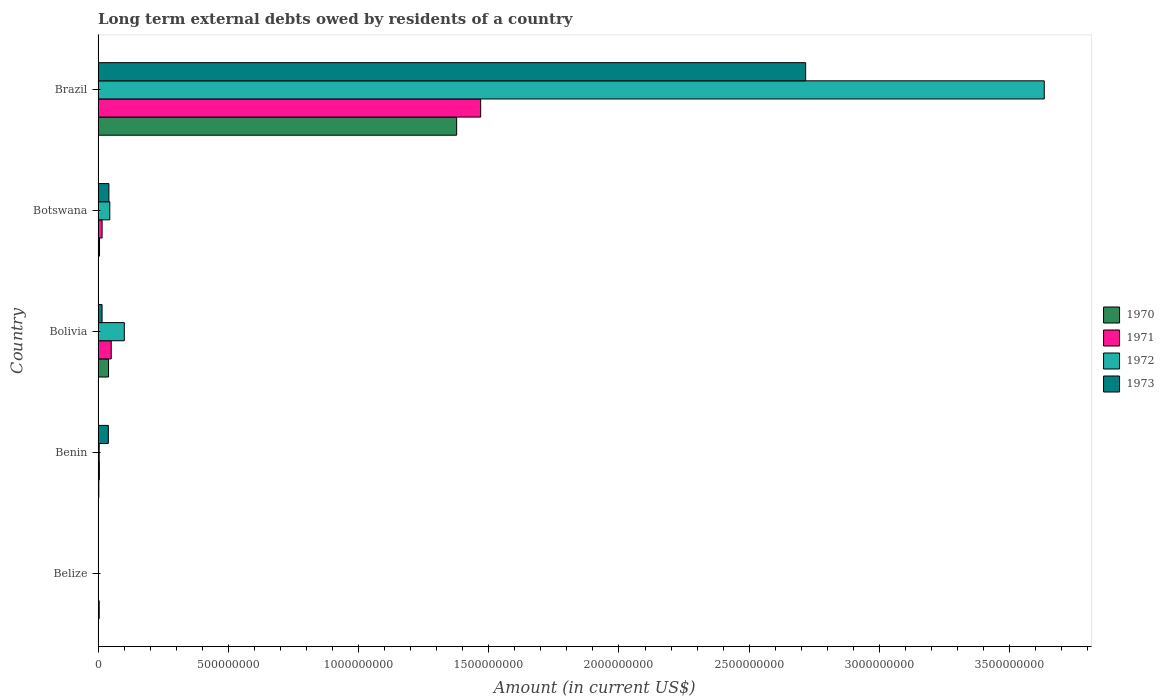How many different coloured bars are there?
Make the answer very short. 4. Are the number of bars on each tick of the Y-axis equal?
Provide a succinct answer. No. In how many cases, is the number of bars for a given country not equal to the number of legend labels?
Keep it short and to the point. 1. What is the amount of long-term external debts owed by residents in 1973 in Bolivia?
Your answer should be compact. 1.53e+07. Across all countries, what is the maximum amount of long-term external debts owed by residents in 1973?
Give a very brief answer. 2.72e+09. Across all countries, what is the minimum amount of long-term external debts owed by residents in 1970?
Provide a short and direct response. 2.87e+06. In which country was the amount of long-term external debts owed by residents in 1971 maximum?
Keep it short and to the point. Brazil. What is the total amount of long-term external debts owed by residents in 1970 in the graph?
Make the answer very short. 1.43e+09. What is the difference between the amount of long-term external debts owed by residents in 1970 in Belize and that in Brazil?
Give a very brief answer. -1.37e+09. What is the difference between the amount of long-term external debts owed by residents in 1970 in Belize and the amount of long-term external debts owed by residents in 1972 in Benin?
Give a very brief answer. 2.40e+04. What is the average amount of long-term external debts owed by residents in 1971 per country?
Your answer should be very brief. 3.08e+08. What is the difference between the amount of long-term external debts owed by residents in 1971 and amount of long-term external debts owed by residents in 1970 in Bolivia?
Keep it short and to the point. 1.03e+07. In how many countries, is the amount of long-term external debts owed by residents in 1973 greater than 2400000000 US$?
Offer a terse response. 1. What is the ratio of the amount of long-term external debts owed by residents in 1972 in Benin to that in Bolivia?
Your answer should be compact. 0.04. Is the amount of long-term external debts owed by residents in 1973 in Bolivia less than that in Brazil?
Provide a short and direct response. Yes. What is the difference between the highest and the second highest amount of long-term external debts owed by residents in 1970?
Your answer should be compact. 1.34e+09. What is the difference between the highest and the lowest amount of long-term external debts owed by residents in 1971?
Provide a short and direct response. 1.47e+09. Is it the case that in every country, the sum of the amount of long-term external debts owed by residents in 1971 and amount of long-term external debts owed by residents in 1972 is greater than the sum of amount of long-term external debts owed by residents in 1973 and amount of long-term external debts owed by residents in 1970?
Your response must be concise. No. Is it the case that in every country, the sum of the amount of long-term external debts owed by residents in 1973 and amount of long-term external debts owed by residents in 1972 is greater than the amount of long-term external debts owed by residents in 1971?
Your response must be concise. No. What is the difference between two consecutive major ticks on the X-axis?
Your response must be concise. 5.00e+08. Does the graph contain any zero values?
Offer a terse response. Yes. Does the graph contain grids?
Provide a succinct answer. No. Where does the legend appear in the graph?
Provide a short and direct response. Center right. How are the legend labels stacked?
Your answer should be compact. Vertical. What is the title of the graph?
Make the answer very short. Long term external debts owed by residents of a country. What is the label or title of the Y-axis?
Your answer should be very brief. Country. What is the Amount (in current US$) of 1970 in Belize?
Keep it short and to the point. 4.30e+06. What is the Amount (in current US$) in 1971 in Belize?
Offer a terse response. 0. What is the Amount (in current US$) in 1973 in Belize?
Keep it short and to the point. 0. What is the Amount (in current US$) of 1970 in Benin?
Your response must be concise. 2.87e+06. What is the Amount (in current US$) of 1971 in Benin?
Your response must be concise. 4.99e+06. What is the Amount (in current US$) in 1972 in Benin?
Ensure brevity in your answer.  4.28e+06. What is the Amount (in current US$) in 1973 in Benin?
Make the answer very short. 3.93e+07. What is the Amount (in current US$) in 1970 in Bolivia?
Make the answer very short. 4.01e+07. What is the Amount (in current US$) in 1971 in Bolivia?
Keep it short and to the point. 5.04e+07. What is the Amount (in current US$) in 1972 in Bolivia?
Provide a succinct answer. 1.01e+08. What is the Amount (in current US$) of 1973 in Bolivia?
Your answer should be very brief. 1.53e+07. What is the Amount (in current US$) of 1970 in Botswana?
Offer a very short reply. 5.57e+06. What is the Amount (in current US$) of 1971 in Botswana?
Provide a short and direct response. 1.54e+07. What is the Amount (in current US$) in 1972 in Botswana?
Make the answer very short. 4.50e+07. What is the Amount (in current US$) of 1973 in Botswana?
Provide a succinct answer. 4.15e+07. What is the Amount (in current US$) in 1970 in Brazil?
Offer a terse response. 1.38e+09. What is the Amount (in current US$) in 1971 in Brazil?
Your response must be concise. 1.47e+09. What is the Amount (in current US$) of 1972 in Brazil?
Give a very brief answer. 3.63e+09. What is the Amount (in current US$) of 1973 in Brazil?
Make the answer very short. 2.72e+09. Across all countries, what is the maximum Amount (in current US$) in 1970?
Make the answer very short. 1.38e+09. Across all countries, what is the maximum Amount (in current US$) in 1971?
Offer a terse response. 1.47e+09. Across all countries, what is the maximum Amount (in current US$) of 1972?
Provide a succinct answer. 3.63e+09. Across all countries, what is the maximum Amount (in current US$) of 1973?
Offer a terse response. 2.72e+09. Across all countries, what is the minimum Amount (in current US$) in 1970?
Your answer should be very brief. 2.87e+06. Across all countries, what is the minimum Amount (in current US$) in 1972?
Your answer should be compact. 0. Across all countries, what is the minimum Amount (in current US$) of 1973?
Provide a succinct answer. 0. What is the total Amount (in current US$) in 1970 in the graph?
Offer a very short reply. 1.43e+09. What is the total Amount (in current US$) in 1971 in the graph?
Your answer should be very brief. 1.54e+09. What is the total Amount (in current US$) in 1972 in the graph?
Provide a succinct answer. 3.78e+09. What is the total Amount (in current US$) in 1973 in the graph?
Give a very brief answer. 2.81e+09. What is the difference between the Amount (in current US$) of 1970 in Belize and that in Benin?
Your answer should be compact. 1.43e+06. What is the difference between the Amount (in current US$) in 1970 in Belize and that in Bolivia?
Provide a succinct answer. -3.58e+07. What is the difference between the Amount (in current US$) of 1970 in Belize and that in Botswana?
Offer a very short reply. -1.27e+06. What is the difference between the Amount (in current US$) in 1970 in Belize and that in Brazil?
Offer a terse response. -1.37e+09. What is the difference between the Amount (in current US$) in 1970 in Benin and that in Bolivia?
Provide a succinct answer. -3.72e+07. What is the difference between the Amount (in current US$) in 1971 in Benin and that in Bolivia?
Provide a short and direct response. -4.54e+07. What is the difference between the Amount (in current US$) of 1972 in Benin and that in Bolivia?
Ensure brevity in your answer.  -9.64e+07. What is the difference between the Amount (in current US$) in 1973 in Benin and that in Bolivia?
Your answer should be very brief. 2.40e+07. What is the difference between the Amount (in current US$) in 1970 in Benin and that in Botswana?
Offer a very short reply. -2.70e+06. What is the difference between the Amount (in current US$) in 1971 in Benin and that in Botswana?
Offer a very short reply. -1.04e+07. What is the difference between the Amount (in current US$) in 1972 in Benin and that in Botswana?
Provide a succinct answer. -4.07e+07. What is the difference between the Amount (in current US$) of 1973 in Benin and that in Botswana?
Provide a short and direct response. -2.15e+06. What is the difference between the Amount (in current US$) of 1970 in Benin and that in Brazil?
Give a very brief answer. -1.37e+09. What is the difference between the Amount (in current US$) of 1971 in Benin and that in Brazil?
Your response must be concise. -1.46e+09. What is the difference between the Amount (in current US$) of 1972 in Benin and that in Brazil?
Give a very brief answer. -3.63e+09. What is the difference between the Amount (in current US$) in 1973 in Benin and that in Brazil?
Provide a short and direct response. -2.68e+09. What is the difference between the Amount (in current US$) in 1970 in Bolivia and that in Botswana?
Ensure brevity in your answer.  3.45e+07. What is the difference between the Amount (in current US$) in 1971 in Bolivia and that in Botswana?
Ensure brevity in your answer.  3.50e+07. What is the difference between the Amount (in current US$) in 1972 in Bolivia and that in Botswana?
Your answer should be compact. 5.57e+07. What is the difference between the Amount (in current US$) in 1973 in Bolivia and that in Botswana?
Provide a succinct answer. -2.62e+07. What is the difference between the Amount (in current US$) in 1970 in Bolivia and that in Brazil?
Keep it short and to the point. -1.34e+09. What is the difference between the Amount (in current US$) in 1971 in Bolivia and that in Brazil?
Make the answer very short. -1.42e+09. What is the difference between the Amount (in current US$) in 1972 in Bolivia and that in Brazil?
Your response must be concise. -3.53e+09. What is the difference between the Amount (in current US$) of 1973 in Bolivia and that in Brazil?
Make the answer very short. -2.70e+09. What is the difference between the Amount (in current US$) of 1970 in Botswana and that in Brazil?
Give a very brief answer. -1.37e+09. What is the difference between the Amount (in current US$) in 1971 in Botswana and that in Brazil?
Ensure brevity in your answer.  -1.45e+09. What is the difference between the Amount (in current US$) of 1972 in Botswana and that in Brazil?
Make the answer very short. -3.59e+09. What is the difference between the Amount (in current US$) in 1973 in Botswana and that in Brazil?
Offer a very short reply. -2.68e+09. What is the difference between the Amount (in current US$) of 1970 in Belize and the Amount (in current US$) of 1971 in Benin?
Provide a succinct answer. -6.88e+05. What is the difference between the Amount (in current US$) in 1970 in Belize and the Amount (in current US$) in 1972 in Benin?
Provide a short and direct response. 2.40e+04. What is the difference between the Amount (in current US$) of 1970 in Belize and the Amount (in current US$) of 1973 in Benin?
Keep it short and to the point. -3.50e+07. What is the difference between the Amount (in current US$) in 1970 in Belize and the Amount (in current US$) in 1971 in Bolivia?
Make the answer very short. -4.61e+07. What is the difference between the Amount (in current US$) of 1970 in Belize and the Amount (in current US$) of 1972 in Bolivia?
Provide a succinct answer. -9.63e+07. What is the difference between the Amount (in current US$) in 1970 in Belize and the Amount (in current US$) in 1973 in Bolivia?
Offer a terse response. -1.10e+07. What is the difference between the Amount (in current US$) of 1970 in Belize and the Amount (in current US$) of 1971 in Botswana?
Make the answer very short. -1.11e+07. What is the difference between the Amount (in current US$) in 1970 in Belize and the Amount (in current US$) in 1972 in Botswana?
Provide a succinct answer. -4.07e+07. What is the difference between the Amount (in current US$) of 1970 in Belize and the Amount (in current US$) of 1973 in Botswana?
Provide a short and direct response. -3.72e+07. What is the difference between the Amount (in current US$) in 1970 in Belize and the Amount (in current US$) in 1971 in Brazil?
Provide a short and direct response. -1.46e+09. What is the difference between the Amount (in current US$) of 1970 in Belize and the Amount (in current US$) of 1972 in Brazil?
Ensure brevity in your answer.  -3.63e+09. What is the difference between the Amount (in current US$) of 1970 in Belize and the Amount (in current US$) of 1973 in Brazil?
Make the answer very short. -2.71e+09. What is the difference between the Amount (in current US$) in 1970 in Benin and the Amount (in current US$) in 1971 in Bolivia?
Your response must be concise. -4.75e+07. What is the difference between the Amount (in current US$) of 1970 in Benin and the Amount (in current US$) of 1972 in Bolivia?
Ensure brevity in your answer.  -9.78e+07. What is the difference between the Amount (in current US$) in 1970 in Benin and the Amount (in current US$) in 1973 in Bolivia?
Make the answer very short. -1.24e+07. What is the difference between the Amount (in current US$) in 1971 in Benin and the Amount (in current US$) in 1972 in Bolivia?
Keep it short and to the point. -9.57e+07. What is the difference between the Amount (in current US$) in 1971 in Benin and the Amount (in current US$) in 1973 in Bolivia?
Ensure brevity in your answer.  -1.03e+07. What is the difference between the Amount (in current US$) of 1972 in Benin and the Amount (in current US$) of 1973 in Bolivia?
Make the answer very short. -1.10e+07. What is the difference between the Amount (in current US$) of 1970 in Benin and the Amount (in current US$) of 1971 in Botswana?
Offer a very short reply. -1.25e+07. What is the difference between the Amount (in current US$) in 1970 in Benin and the Amount (in current US$) in 1972 in Botswana?
Provide a short and direct response. -4.21e+07. What is the difference between the Amount (in current US$) of 1970 in Benin and the Amount (in current US$) of 1973 in Botswana?
Your answer should be very brief. -3.86e+07. What is the difference between the Amount (in current US$) of 1971 in Benin and the Amount (in current US$) of 1972 in Botswana?
Your response must be concise. -4.00e+07. What is the difference between the Amount (in current US$) in 1971 in Benin and the Amount (in current US$) in 1973 in Botswana?
Your answer should be very brief. -3.65e+07. What is the difference between the Amount (in current US$) in 1972 in Benin and the Amount (in current US$) in 1973 in Botswana?
Make the answer very short. -3.72e+07. What is the difference between the Amount (in current US$) of 1970 in Benin and the Amount (in current US$) of 1971 in Brazil?
Make the answer very short. -1.47e+09. What is the difference between the Amount (in current US$) in 1970 in Benin and the Amount (in current US$) in 1972 in Brazil?
Ensure brevity in your answer.  -3.63e+09. What is the difference between the Amount (in current US$) of 1970 in Benin and the Amount (in current US$) of 1973 in Brazil?
Give a very brief answer. -2.71e+09. What is the difference between the Amount (in current US$) of 1971 in Benin and the Amount (in current US$) of 1972 in Brazil?
Provide a succinct answer. -3.63e+09. What is the difference between the Amount (in current US$) in 1971 in Benin and the Amount (in current US$) in 1973 in Brazil?
Ensure brevity in your answer.  -2.71e+09. What is the difference between the Amount (in current US$) of 1972 in Benin and the Amount (in current US$) of 1973 in Brazil?
Offer a very short reply. -2.71e+09. What is the difference between the Amount (in current US$) of 1970 in Bolivia and the Amount (in current US$) of 1971 in Botswana?
Provide a succinct answer. 2.47e+07. What is the difference between the Amount (in current US$) in 1970 in Bolivia and the Amount (in current US$) in 1972 in Botswana?
Ensure brevity in your answer.  -4.88e+06. What is the difference between the Amount (in current US$) of 1970 in Bolivia and the Amount (in current US$) of 1973 in Botswana?
Offer a terse response. -1.40e+06. What is the difference between the Amount (in current US$) in 1971 in Bolivia and the Amount (in current US$) in 1972 in Botswana?
Your response must be concise. 5.46e+06. What is the difference between the Amount (in current US$) in 1971 in Bolivia and the Amount (in current US$) in 1973 in Botswana?
Your answer should be very brief. 8.94e+06. What is the difference between the Amount (in current US$) in 1972 in Bolivia and the Amount (in current US$) in 1973 in Botswana?
Your answer should be very brief. 5.92e+07. What is the difference between the Amount (in current US$) of 1970 in Bolivia and the Amount (in current US$) of 1971 in Brazil?
Make the answer very short. -1.43e+09. What is the difference between the Amount (in current US$) of 1970 in Bolivia and the Amount (in current US$) of 1972 in Brazil?
Make the answer very short. -3.59e+09. What is the difference between the Amount (in current US$) of 1970 in Bolivia and the Amount (in current US$) of 1973 in Brazil?
Give a very brief answer. -2.68e+09. What is the difference between the Amount (in current US$) of 1971 in Bolivia and the Amount (in current US$) of 1972 in Brazil?
Provide a succinct answer. -3.58e+09. What is the difference between the Amount (in current US$) in 1971 in Bolivia and the Amount (in current US$) in 1973 in Brazil?
Your answer should be very brief. -2.67e+09. What is the difference between the Amount (in current US$) in 1972 in Bolivia and the Amount (in current US$) in 1973 in Brazil?
Ensure brevity in your answer.  -2.62e+09. What is the difference between the Amount (in current US$) in 1970 in Botswana and the Amount (in current US$) in 1971 in Brazil?
Ensure brevity in your answer.  -1.46e+09. What is the difference between the Amount (in current US$) of 1970 in Botswana and the Amount (in current US$) of 1972 in Brazil?
Provide a succinct answer. -3.63e+09. What is the difference between the Amount (in current US$) in 1970 in Botswana and the Amount (in current US$) in 1973 in Brazil?
Your answer should be very brief. -2.71e+09. What is the difference between the Amount (in current US$) in 1971 in Botswana and the Amount (in current US$) in 1972 in Brazil?
Offer a terse response. -3.62e+09. What is the difference between the Amount (in current US$) in 1971 in Botswana and the Amount (in current US$) in 1973 in Brazil?
Your answer should be compact. -2.70e+09. What is the difference between the Amount (in current US$) of 1972 in Botswana and the Amount (in current US$) of 1973 in Brazil?
Your response must be concise. -2.67e+09. What is the average Amount (in current US$) in 1970 per country?
Provide a succinct answer. 2.86e+08. What is the average Amount (in current US$) of 1971 per country?
Your answer should be very brief. 3.08e+08. What is the average Amount (in current US$) in 1972 per country?
Keep it short and to the point. 7.57e+08. What is the average Amount (in current US$) of 1973 per country?
Your answer should be compact. 5.63e+08. What is the difference between the Amount (in current US$) of 1970 and Amount (in current US$) of 1971 in Benin?
Provide a succinct answer. -2.12e+06. What is the difference between the Amount (in current US$) in 1970 and Amount (in current US$) in 1972 in Benin?
Ensure brevity in your answer.  -1.41e+06. What is the difference between the Amount (in current US$) in 1970 and Amount (in current US$) in 1973 in Benin?
Give a very brief answer. -3.65e+07. What is the difference between the Amount (in current US$) of 1971 and Amount (in current US$) of 1972 in Benin?
Make the answer very short. 7.12e+05. What is the difference between the Amount (in current US$) of 1971 and Amount (in current US$) of 1973 in Benin?
Your answer should be very brief. -3.43e+07. What is the difference between the Amount (in current US$) in 1972 and Amount (in current US$) in 1973 in Benin?
Provide a short and direct response. -3.51e+07. What is the difference between the Amount (in current US$) in 1970 and Amount (in current US$) in 1971 in Bolivia?
Your response must be concise. -1.03e+07. What is the difference between the Amount (in current US$) in 1970 and Amount (in current US$) in 1972 in Bolivia?
Offer a very short reply. -6.06e+07. What is the difference between the Amount (in current US$) of 1970 and Amount (in current US$) of 1973 in Bolivia?
Offer a terse response. 2.48e+07. What is the difference between the Amount (in current US$) in 1971 and Amount (in current US$) in 1972 in Bolivia?
Offer a very short reply. -5.02e+07. What is the difference between the Amount (in current US$) of 1971 and Amount (in current US$) of 1973 in Bolivia?
Provide a short and direct response. 3.51e+07. What is the difference between the Amount (in current US$) of 1972 and Amount (in current US$) of 1973 in Bolivia?
Your response must be concise. 8.53e+07. What is the difference between the Amount (in current US$) in 1970 and Amount (in current US$) in 1971 in Botswana?
Ensure brevity in your answer.  -9.82e+06. What is the difference between the Amount (in current US$) in 1970 and Amount (in current US$) in 1972 in Botswana?
Provide a short and direct response. -3.94e+07. What is the difference between the Amount (in current US$) of 1970 and Amount (in current US$) of 1973 in Botswana?
Ensure brevity in your answer.  -3.59e+07. What is the difference between the Amount (in current US$) of 1971 and Amount (in current US$) of 1972 in Botswana?
Offer a terse response. -2.96e+07. What is the difference between the Amount (in current US$) of 1971 and Amount (in current US$) of 1973 in Botswana?
Ensure brevity in your answer.  -2.61e+07. What is the difference between the Amount (in current US$) in 1972 and Amount (in current US$) in 1973 in Botswana?
Provide a succinct answer. 3.47e+06. What is the difference between the Amount (in current US$) in 1970 and Amount (in current US$) in 1971 in Brazil?
Keep it short and to the point. -9.22e+07. What is the difference between the Amount (in current US$) of 1970 and Amount (in current US$) of 1972 in Brazil?
Give a very brief answer. -2.26e+09. What is the difference between the Amount (in current US$) of 1970 and Amount (in current US$) of 1973 in Brazil?
Offer a very short reply. -1.34e+09. What is the difference between the Amount (in current US$) in 1971 and Amount (in current US$) in 1972 in Brazil?
Your response must be concise. -2.16e+09. What is the difference between the Amount (in current US$) in 1971 and Amount (in current US$) in 1973 in Brazil?
Give a very brief answer. -1.25e+09. What is the difference between the Amount (in current US$) in 1972 and Amount (in current US$) in 1973 in Brazil?
Provide a short and direct response. 9.16e+08. What is the ratio of the Amount (in current US$) of 1970 in Belize to that in Benin?
Ensure brevity in your answer.  1.5. What is the ratio of the Amount (in current US$) of 1970 in Belize to that in Bolivia?
Keep it short and to the point. 0.11. What is the ratio of the Amount (in current US$) in 1970 in Belize to that in Botswana?
Your answer should be compact. 0.77. What is the ratio of the Amount (in current US$) in 1970 in Belize to that in Brazil?
Make the answer very short. 0. What is the ratio of the Amount (in current US$) in 1970 in Benin to that in Bolivia?
Provide a succinct answer. 0.07. What is the ratio of the Amount (in current US$) in 1971 in Benin to that in Bolivia?
Provide a short and direct response. 0.1. What is the ratio of the Amount (in current US$) of 1972 in Benin to that in Bolivia?
Ensure brevity in your answer.  0.04. What is the ratio of the Amount (in current US$) of 1973 in Benin to that in Bolivia?
Make the answer very short. 2.57. What is the ratio of the Amount (in current US$) in 1970 in Benin to that in Botswana?
Offer a terse response. 0.52. What is the ratio of the Amount (in current US$) of 1971 in Benin to that in Botswana?
Ensure brevity in your answer.  0.32. What is the ratio of the Amount (in current US$) in 1972 in Benin to that in Botswana?
Offer a terse response. 0.1. What is the ratio of the Amount (in current US$) in 1973 in Benin to that in Botswana?
Your response must be concise. 0.95. What is the ratio of the Amount (in current US$) of 1970 in Benin to that in Brazil?
Make the answer very short. 0. What is the ratio of the Amount (in current US$) in 1971 in Benin to that in Brazil?
Your answer should be compact. 0. What is the ratio of the Amount (in current US$) in 1972 in Benin to that in Brazil?
Provide a short and direct response. 0. What is the ratio of the Amount (in current US$) of 1973 in Benin to that in Brazil?
Provide a short and direct response. 0.01. What is the ratio of the Amount (in current US$) in 1970 in Bolivia to that in Botswana?
Your response must be concise. 7.2. What is the ratio of the Amount (in current US$) in 1971 in Bolivia to that in Botswana?
Offer a terse response. 3.28. What is the ratio of the Amount (in current US$) of 1972 in Bolivia to that in Botswana?
Provide a short and direct response. 2.24. What is the ratio of the Amount (in current US$) of 1973 in Bolivia to that in Botswana?
Ensure brevity in your answer.  0.37. What is the ratio of the Amount (in current US$) in 1970 in Bolivia to that in Brazil?
Give a very brief answer. 0.03. What is the ratio of the Amount (in current US$) in 1971 in Bolivia to that in Brazil?
Ensure brevity in your answer.  0.03. What is the ratio of the Amount (in current US$) in 1972 in Bolivia to that in Brazil?
Keep it short and to the point. 0.03. What is the ratio of the Amount (in current US$) in 1973 in Bolivia to that in Brazil?
Make the answer very short. 0.01. What is the ratio of the Amount (in current US$) of 1970 in Botswana to that in Brazil?
Offer a very short reply. 0. What is the ratio of the Amount (in current US$) in 1971 in Botswana to that in Brazil?
Ensure brevity in your answer.  0.01. What is the ratio of the Amount (in current US$) in 1972 in Botswana to that in Brazil?
Your answer should be very brief. 0.01. What is the ratio of the Amount (in current US$) in 1973 in Botswana to that in Brazil?
Your answer should be compact. 0.02. What is the difference between the highest and the second highest Amount (in current US$) of 1970?
Make the answer very short. 1.34e+09. What is the difference between the highest and the second highest Amount (in current US$) of 1971?
Offer a terse response. 1.42e+09. What is the difference between the highest and the second highest Amount (in current US$) of 1972?
Provide a succinct answer. 3.53e+09. What is the difference between the highest and the second highest Amount (in current US$) in 1973?
Make the answer very short. 2.68e+09. What is the difference between the highest and the lowest Amount (in current US$) of 1970?
Your response must be concise. 1.37e+09. What is the difference between the highest and the lowest Amount (in current US$) of 1971?
Provide a short and direct response. 1.47e+09. What is the difference between the highest and the lowest Amount (in current US$) of 1972?
Ensure brevity in your answer.  3.63e+09. What is the difference between the highest and the lowest Amount (in current US$) of 1973?
Provide a short and direct response. 2.72e+09. 